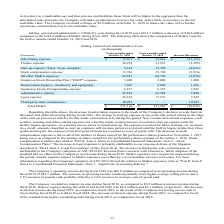According to Sanderson Farms's financial document, Why was there a decrease in advertising expense? result of the Company's decision to scale back its television and radio advertising during fiscal 2019.. The document states: "above, the decrease in advertising expense is the result of the Company's decision to scale back its television and radio advertising during fiscal 20..." Also, What was the total SG&A for fiscal 2019 and 2018 respectively? The document shows two values: $211,141 and $221,965 (in thousands). From the document: "Total SG&A $ 211,141 $ 221,965 $ (10,824) Total SG&A $ 211,141 $ 221,965 $ (10,824)..." Also, What was the legal expense for fiscal 2019 and 2018 respectively? The document shows two values: 25,102 and 17,573 (in thousands). From the document: "Legal expense 25,102 17,573 7,529 Legal expense 25,102 17,573 7,529..." Also, can you calculate: What is the average legal expense for fiscal 2019 and 2018? To answer this question, I need to perform calculations using the financial data. The calculation is: (25,102+17,573)/2, which equals 21337.5 (in thousands). This is based on the information: "Legal expense 25,102 17,573 7,529 Legal expense 25,102 17,573 7,529..." The key data points involved are: 17,573, 25,102. Also, can you calculate: What is the average Administrative salaries for fiscal 2019 and 2018? To answer this question, I need to perform calculations using the financial data. The calculation is: (45,108+42,288)/2, which equals 43698 (in thousands). This is based on the information: "Administrative salaries 45,108 42,288 2,820 Administrative salaries 45,108 42,288 2,820..." The key data points involved are: 42,288, 45,108. Also, can you calculate: What is the average Advertising expense for fiscal 2019 and 2018? To answer this question, I need to perform calculations using the financial data. The calculation is: (11,071+ 32,624)/2, which equals 21847.5 (in thousands). This is based on the information: "Advertising expense $ 11,071 $ 32,624 $ (21,553) Advertising expense $ 11,071 $ 32,624 $ (21,553)..." The key data points involved are: 11,071, 32,624. 